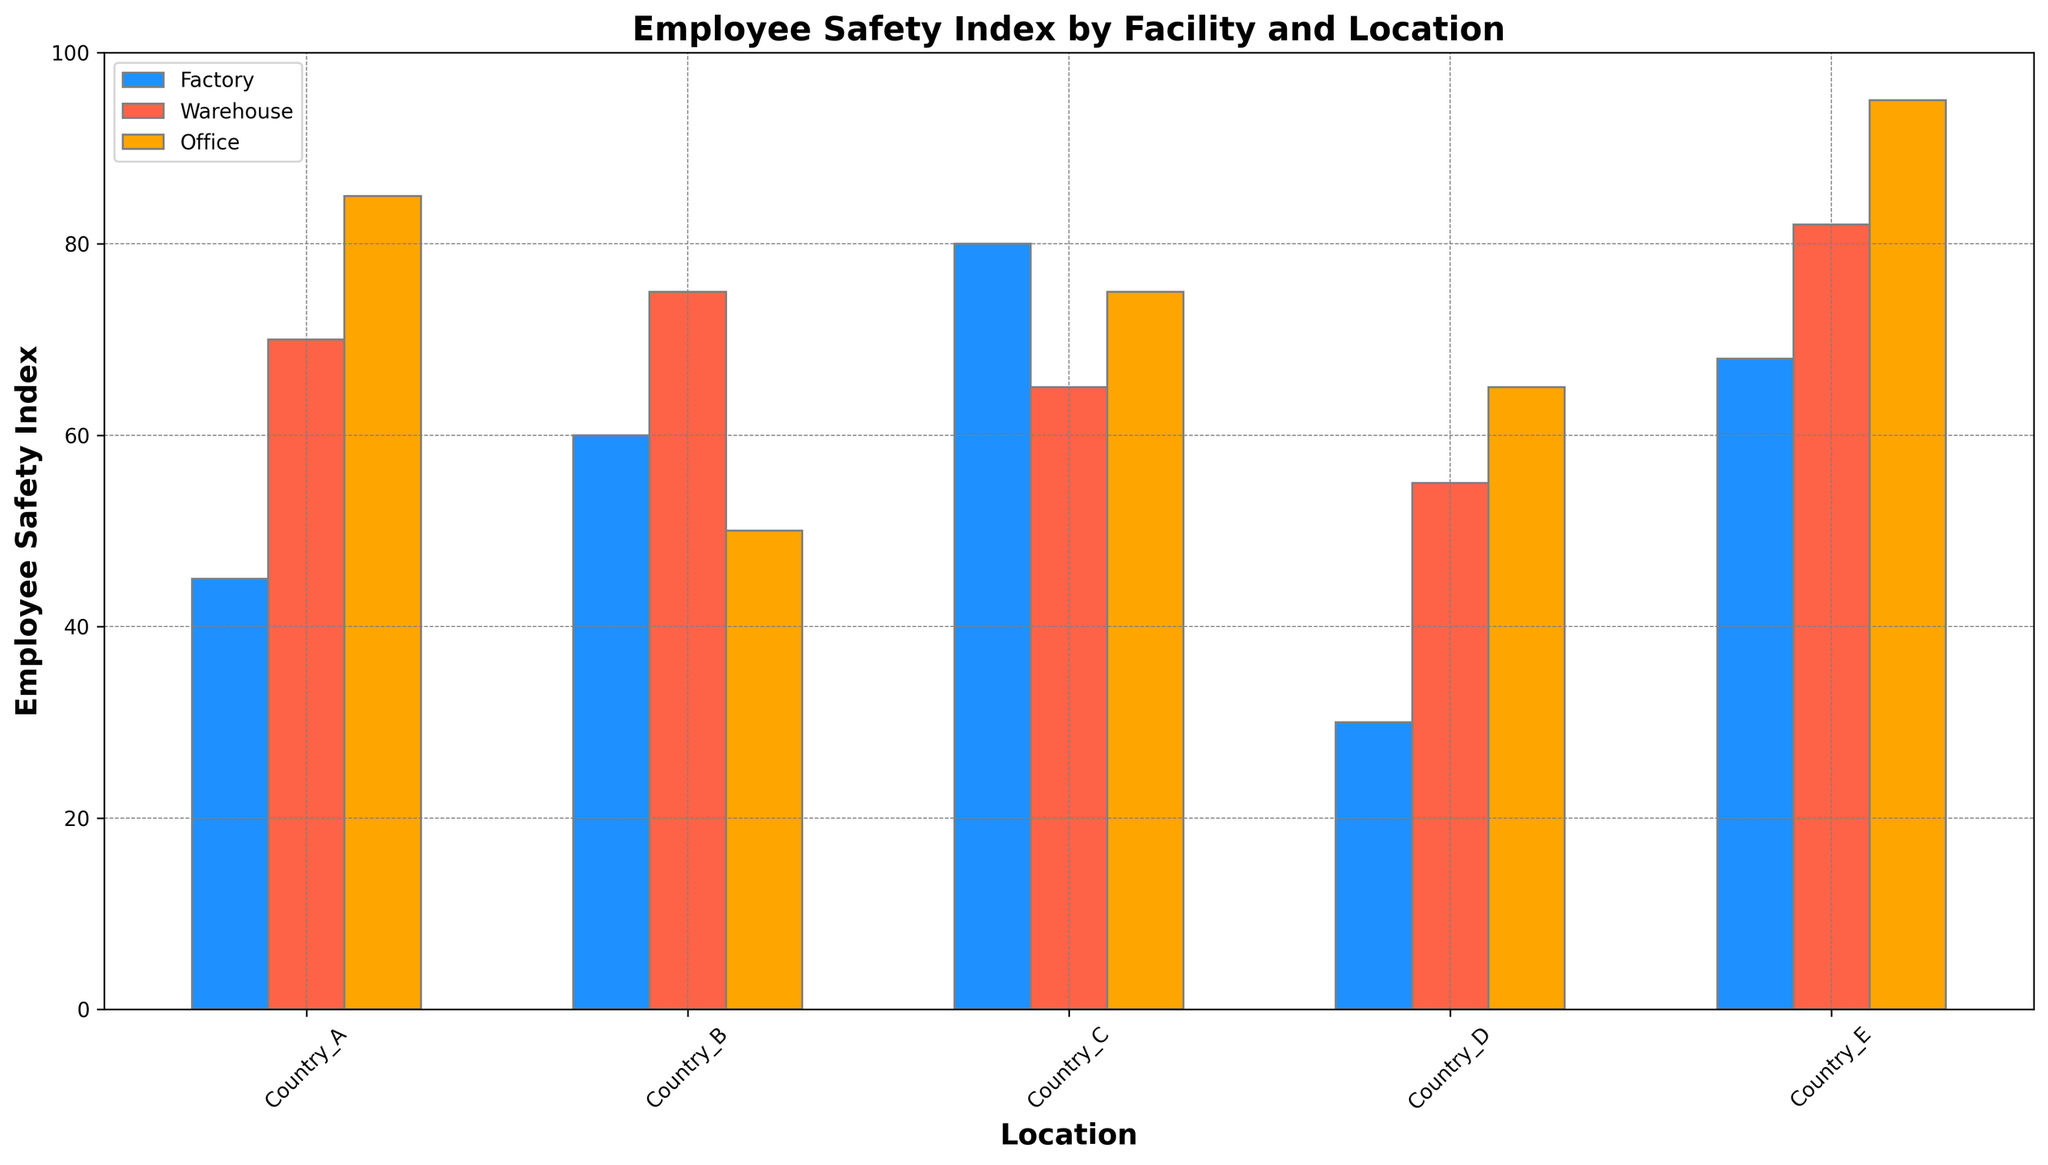What is the Employee Safety Index for the Factory in Country_D? The bar corresponding to the Factory in Country_D is the one at the far left of the grouped bars for Country_D. It is colored in blue and reaches up to 30 on the y-axis. Therefore, the Employee Safety Index for the Factory in Country_D is 30.
Answer: 30 Which facility in Country_A has the highest Employee Safety Index? In Country_A, the grouped bars for Factory, Warehouse, and Office are colored in blue, red, and orange respectively. The bar for the Office is the highest among them, reaching up to 85 on the y-axis. Thus, the Office in Country_A has the highest Employee Safety Index.
Answer: Office Compare the Employee Safety Indices between the Warehouse in Country_C and the Office in Country_C. Which one is higher? Looking at Country_C, the red bar represents the Warehouse and the orange bar represents the Office. The red bar reaches up to 65 on the y-axis, while the orange bar reaches up to 75. Therefore, the Employee Safety Index for the Office is higher than that for the Warehouse.
Answer: Office What is the average Employee Safety Index for all facilities in Country_B? For Country_B, the Employee Safety Indices for Factory, Warehouse, and Office are 60, 75, and 50 respectively. The average can be calculated by summing these values and dividing by 3. (60 + 75 + 50) / 3 = 185 / 3 ≈ 61.67.
Answer: ≈ 61.67 Identify the facility-location combination with the lowest Employee Safety Index. Scanning through all the bars, the shortest bar is the blue one in Country_D representing the Factory, which reaches up to 30 on the y-axis. Therefore, the Factory in Country_D has the lowest Employee Safety Index.
Answer: Factory in Country_D How does the Employee Safety Index of the Factory in Country_E compare to the Factory in Country_B? The blue bar for the Factory in Country_E reaches up to 68 on the y-axis, while the blue bar for the Factory in Country_B reaches up to 60. Thus, the Factory in Country_E has a higher Employee Safety Index than the Factory in Country_B.
Answer: Country_E is higher What is the difference between the highest and lowest Employee Safety Indices in this plot? The highest bar corresponds to the Office in Country_E, reaching up to 95, and the lowest bar corresponds to the Factory in Country_D, which reaches up to 30. The difference is 95 - 30 = 65.
Answer: 65 Which facility has the most consistent Employee Safety Index across all locations? To determine consistency, we observe the height of bars for each facility across different locations (blue for Factory, red for Warehouse, orange for Office). The Office (orange bars) appears to have a less variable height, consistently around mid to high values in all locations. Therefore, the Office has the most consistent Employee Safety Index.
Answer: Office Are there any facilities where the Employee Safety Index is above 80 in all locations? Checking each facility and location, only the Warehouse in Country_E and the Office in Country_A and Country_E have an Employee Safety Index above 80. No single facility has indices above 80 across all locations.
Answer: No What is the combined Employee Safety Index for the Factory and Warehouse in Country_A? In Country_A, the Employee Safety Index for the Factory is 45 and for the Warehouse is 70. The combined value is 45 + 70 = 115.
Answer: 115 